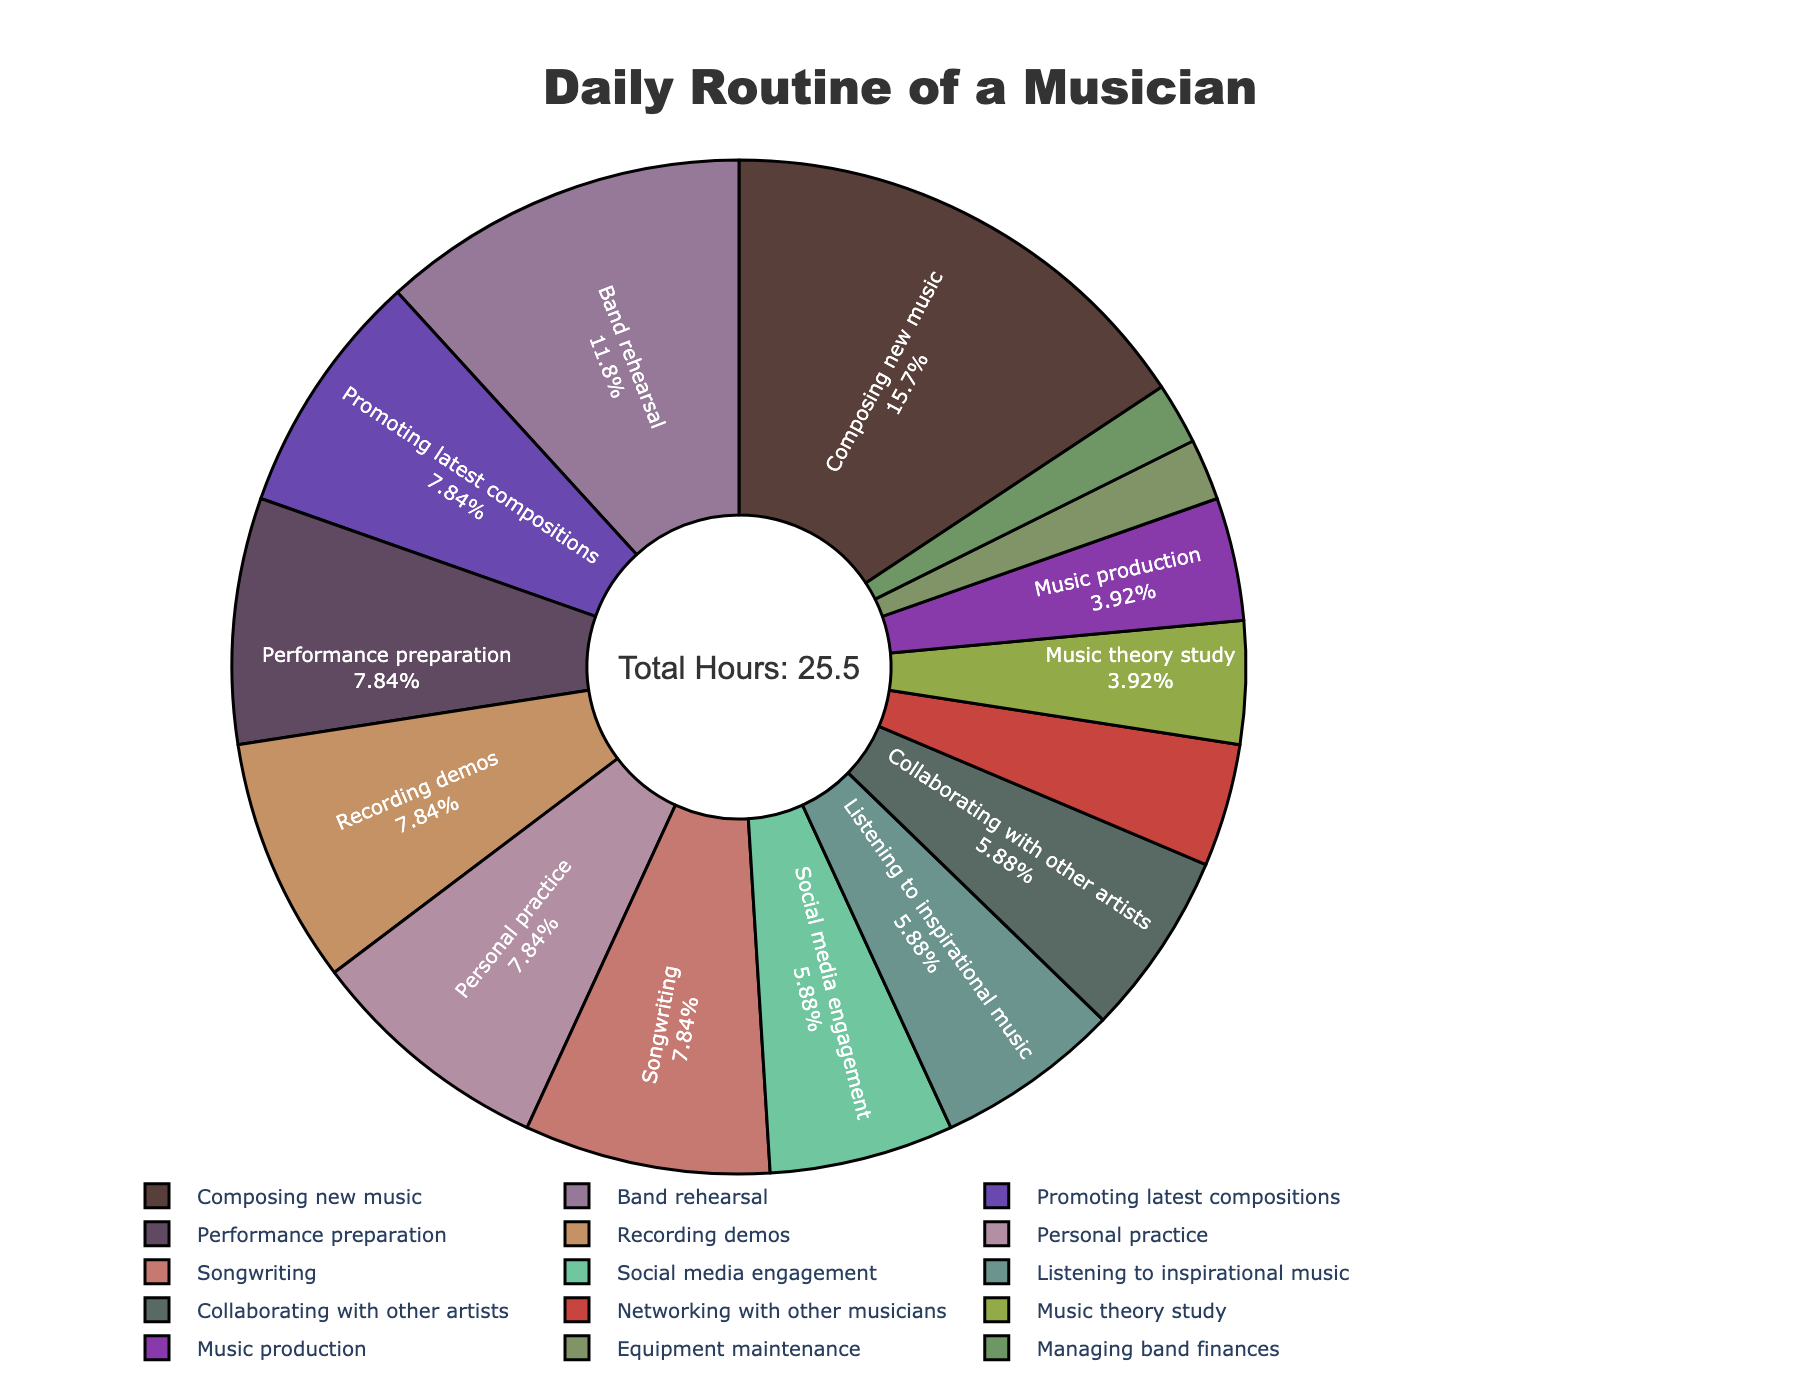what activity takes up the most time in a musician's daily routine? By looking at the pie chart, we can see that the activity with the largest portion is "Composing new music," which occupies the biggest segment among all activities.
Answer: Composing new music what is the total amount of time spent on 'Recording demos' and 'Performance preparation'? From the pie chart, 'Recording demos' accounts for 2 hours, and 'Performance preparation' also accounts for 2 hours. Adding these together, we get 2 + 2 = 4 hours.
Answer: 4 hours which activity has a smaller portion: 'Networking with other musicians' or 'Music theory study'? The pie chart shows that 'Networking with other musicians' takes up 1 hour, whereas 'Music theory study' takes up 1 hour. By comparing the portions, it is evident that they are equally sized.
Answer: Equal what percentage of the day is spent on 'Songwriting'? Referring to the pie chart, we need to identify the 'Songwriting' segment. 'Songwriting' accounts for 2 hours, displayed on the pie chart by its percentage. Given a total of 24 hours, 2 hours out of 24 is approximately 8.33%.
Answer: 8.33% how do the hours spent on 'Band rehearsal' compare to 'Personal practice'? From the pie chart, 'Band rehearsal' accounts for 3 hours, while 'Personal practice' accounts for 2 hours. Comparing these, 'Band rehearsal' occupies a larger portion of the day.
Answer: Band rehearsal > Personal practice what is the combined time spent on activities related to social media ('Promoting latest compositions' and 'Social media engagement')? According to the pie chart, 'Promoting latest compositions' takes up 2 hours, and 'Social media engagement' takes up 1.5 hours. Adding these together gives us 2 + 1.5 = 3.5 hours.
Answer: 3.5 hours which activity has the smallest portion in the musician's daily routine? By examining the sectors of the pie chart, 'Managing band finances' and 'Equipment maintenance' are the smallest portions.
Answer: Managing band finances & Equipment maintenance what are the total hours per day spent on creative activities ('Composing new music', 'Songwriting', 'Music production', and 'Collaborating with other artists')? The pie chart shows the hours for these activities as follows: 'Composing new music' (4 hours), 'Songwriting' (2 hours), 'Music production' (1 hour), and ‘Collaborating with other artists’ (1.5 hours). Summing these gives us 4 + 2 + 1 + 1.5 = 8.5 hours.
Answer: 8.5 hours how does the time spent on 'Listening to inspirational music' compare to 'Collaborating with other artists'? According to the pie chart, both 'Listening to inspirational music' and 'Collaborating with other artists' each take up 1.5 hours. Therefore, these activities occupy equal portions of the musician's day.
Answer: Equal what is the median hours spent on all activities in the pie chart? Listing all hours in ascending order: 0.5, 0.5, 1, 1, 1.5, 1.5, 1.5, 2, 2, 2, 2, 2, 2, 3, 4. The median of these 15 numbers is the 8th value when ordered, which is 2 hours.
Answer: 2 hours 